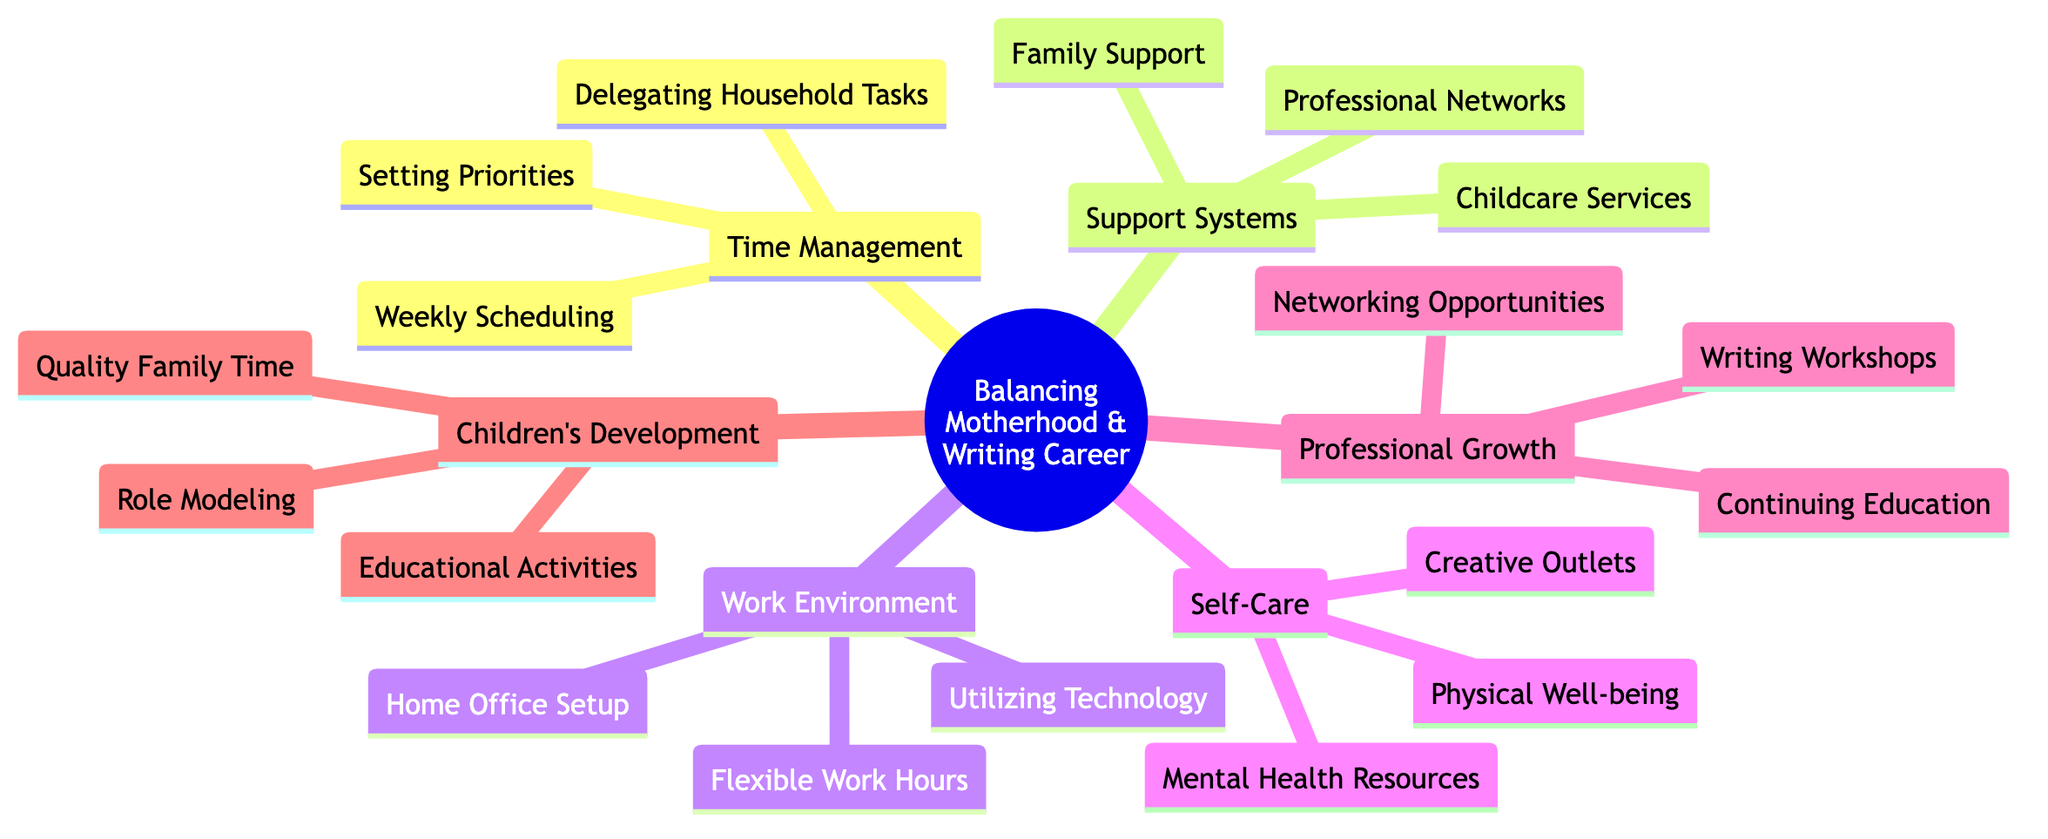What is the central topic of the mind map? The central topic is clearly labeled at the center of the diagram as "Balancing Motherhood and a Professional Writing Career."
Answer: Balancing Motherhood and a Professional Writing Career How many subtopics are there in the mind map? By counting the listed subtopics branching from the central topic, we find there are six: Time Management, Support Systems, Work Environment, Self-Care, Professional Growth, and Children's Development.
Answer: 6 What is one element under the subtopic "Support Systems"? The subtopic "Support Systems" includes three elements: Family Support, Professional Networks, and Childcare Services. Any of these could be a valid answer.
Answer: Family Support (or Professional Networks or Childcare Services) Which subtopic includes "Flexible Work Hours"? "Flexible Work Hours" is an element under the subtopic "Work Environment."
Answer: Work Environment What are two elements included in the "Self-Care" subtopic? The "Self-Care" subtopic consists of three elements: Mental Health Resources, Physical Well-being, and Creative Outlets. Any two of these elements can be chosen as the answer.
Answer: Mental Health Resources, Physical Well-being (or Creative Outlets) What do all subtopics have in common based on the mind map structure? All subtopics serve to address different aspects of balancing motherhood with a writing career, indicating their interconnectedness in supporting the central topic.
Answer: They support the central theme How many elements are listed under the "Professional Growth" subtopic? There are three elements listed under the "Professional Growth" subtopic: Continuing Education, Writing Workshops, and Networking Opportunities.
Answer: 3 Which is the only element that relates to physical health? The element related to physical health under the "Self-Care" subtopic is "Physical Well-being."
Answer: Physical Well-being What is the overall function of the "Children's Development" subtopic in the context of this mind map? The "Children's Development" subtopic emphasizes how motherhood and professional writing can positively influence children's growth through various activities, promoting a well-rounded lifestyle.
Answer: Positive influence on children's growth 